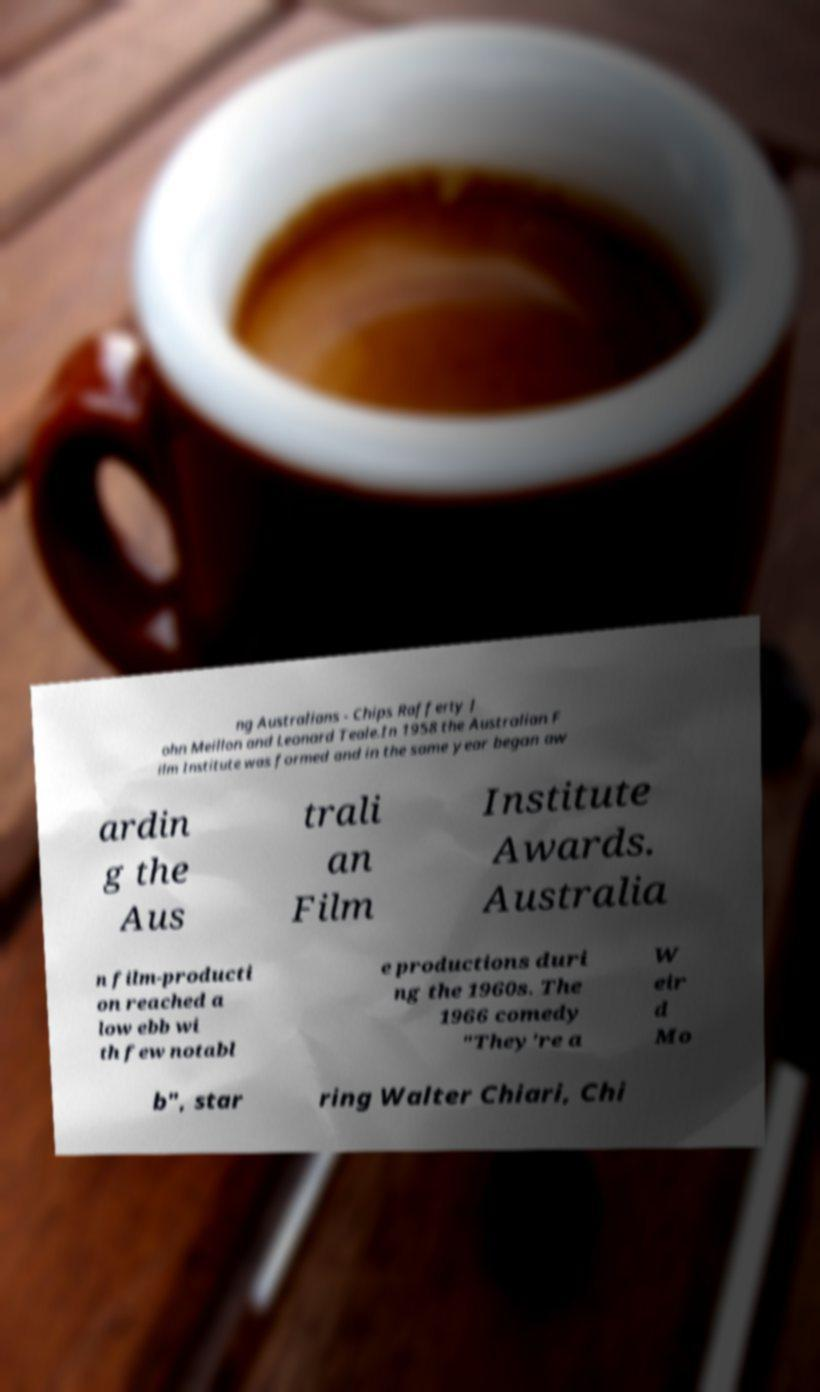Please read and relay the text visible in this image. What does it say? ng Australians - Chips Rafferty J ohn Meillon and Leonard Teale.In 1958 the Australian F ilm Institute was formed and in the same year began aw ardin g the Aus trali an Film Institute Awards. Australia n film-producti on reached a low ebb wi th few notabl e productions duri ng the 1960s. The 1966 comedy "They're a W eir d Mo b", star ring Walter Chiari, Chi 